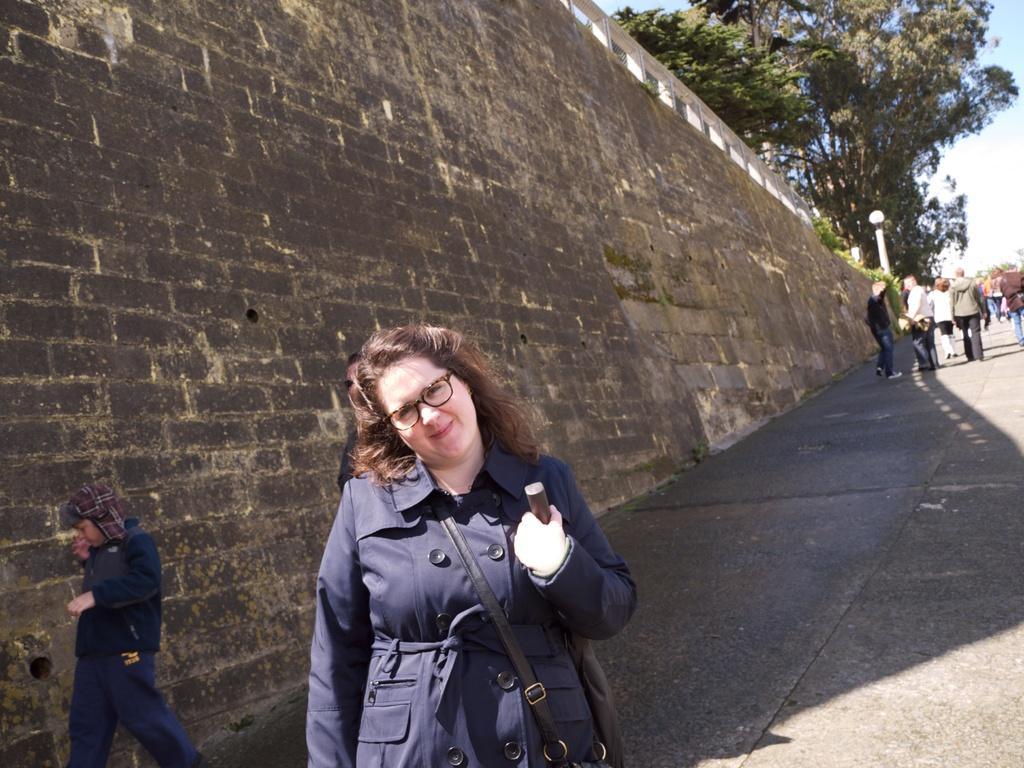Describe this image in one or two sentences. In this picture we can see a woman wore spectacles, holding an object with her hand and smiling and at the back of her we can see the wall, some people on the ground, light pole, trees and in the background we can see the sky. 